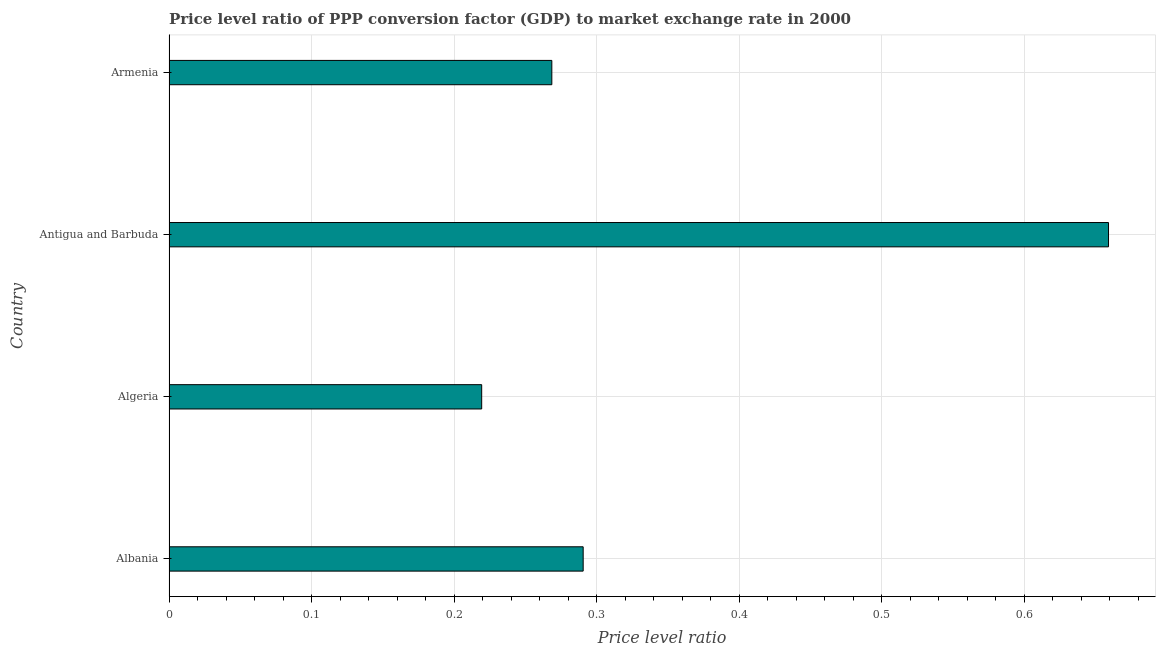Does the graph contain any zero values?
Your response must be concise. No. What is the title of the graph?
Ensure brevity in your answer.  Price level ratio of PPP conversion factor (GDP) to market exchange rate in 2000. What is the label or title of the X-axis?
Make the answer very short. Price level ratio. What is the price level ratio in Armenia?
Make the answer very short. 0.27. Across all countries, what is the maximum price level ratio?
Give a very brief answer. 0.66. Across all countries, what is the minimum price level ratio?
Ensure brevity in your answer.  0.22. In which country was the price level ratio maximum?
Provide a succinct answer. Antigua and Barbuda. In which country was the price level ratio minimum?
Your answer should be compact. Algeria. What is the sum of the price level ratio?
Provide a short and direct response. 1.44. What is the difference between the price level ratio in Antigua and Barbuda and Armenia?
Make the answer very short. 0.39. What is the average price level ratio per country?
Your response must be concise. 0.36. What is the median price level ratio?
Ensure brevity in your answer.  0.28. In how many countries, is the price level ratio greater than 0.04 ?
Your response must be concise. 4. What is the ratio of the price level ratio in Antigua and Barbuda to that in Armenia?
Provide a succinct answer. 2.45. Is the price level ratio in Antigua and Barbuda less than that in Armenia?
Provide a succinct answer. No. Is the difference between the price level ratio in Albania and Armenia greater than the difference between any two countries?
Ensure brevity in your answer.  No. What is the difference between the highest and the second highest price level ratio?
Offer a terse response. 0.37. Is the sum of the price level ratio in Albania and Armenia greater than the maximum price level ratio across all countries?
Your response must be concise. No. What is the difference between the highest and the lowest price level ratio?
Make the answer very short. 0.44. Are all the bars in the graph horizontal?
Provide a succinct answer. Yes. What is the difference between two consecutive major ticks on the X-axis?
Your response must be concise. 0.1. Are the values on the major ticks of X-axis written in scientific E-notation?
Your answer should be compact. No. What is the Price level ratio in Albania?
Provide a short and direct response. 0.29. What is the Price level ratio in Algeria?
Your answer should be very brief. 0.22. What is the Price level ratio in Antigua and Barbuda?
Keep it short and to the point. 0.66. What is the Price level ratio in Armenia?
Give a very brief answer. 0.27. What is the difference between the Price level ratio in Albania and Algeria?
Offer a very short reply. 0.07. What is the difference between the Price level ratio in Albania and Antigua and Barbuda?
Offer a terse response. -0.37. What is the difference between the Price level ratio in Albania and Armenia?
Offer a terse response. 0.02. What is the difference between the Price level ratio in Algeria and Antigua and Barbuda?
Offer a terse response. -0.44. What is the difference between the Price level ratio in Algeria and Armenia?
Keep it short and to the point. -0.05. What is the difference between the Price level ratio in Antigua and Barbuda and Armenia?
Provide a succinct answer. 0.39. What is the ratio of the Price level ratio in Albania to that in Algeria?
Your answer should be very brief. 1.32. What is the ratio of the Price level ratio in Albania to that in Antigua and Barbuda?
Ensure brevity in your answer.  0.44. What is the ratio of the Price level ratio in Albania to that in Armenia?
Offer a very short reply. 1.08. What is the ratio of the Price level ratio in Algeria to that in Antigua and Barbuda?
Offer a terse response. 0.33. What is the ratio of the Price level ratio in Algeria to that in Armenia?
Offer a very short reply. 0.82. What is the ratio of the Price level ratio in Antigua and Barbuda to that in Armenia?
Make the answer very short. 2.45. 